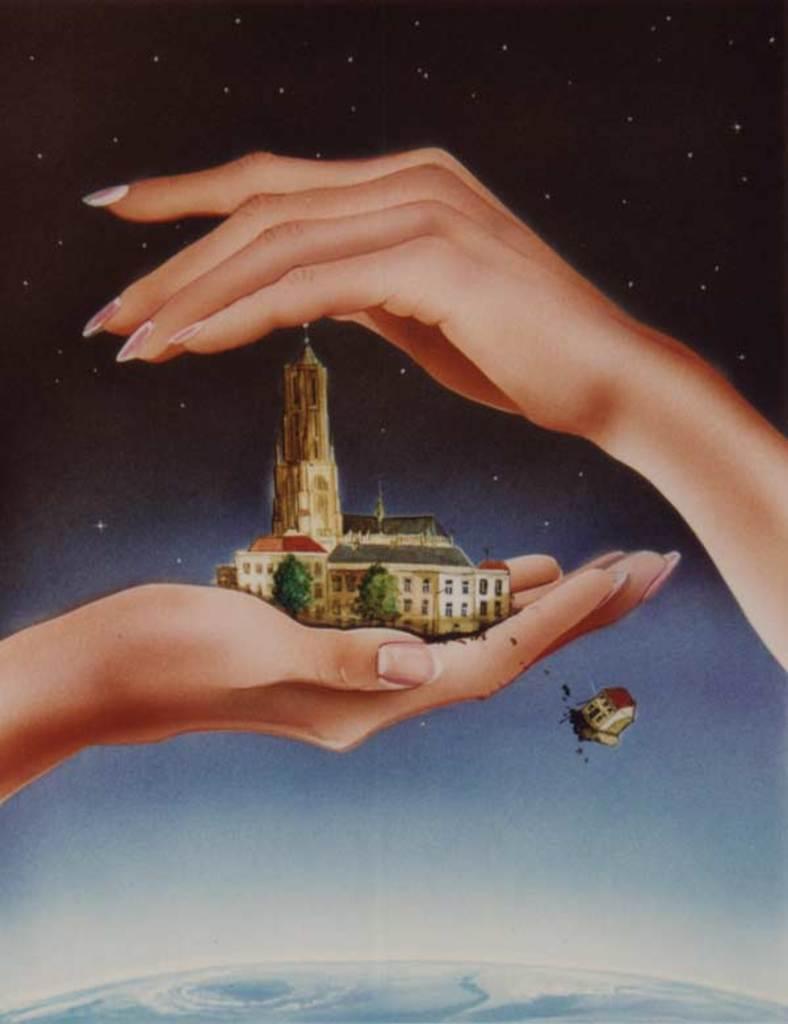How would you summarize this image in a sentence or two? At the bottom of the image there is earth. And there is a person hand with buildings and trees. And also there is another hand. In the background there are stars. 